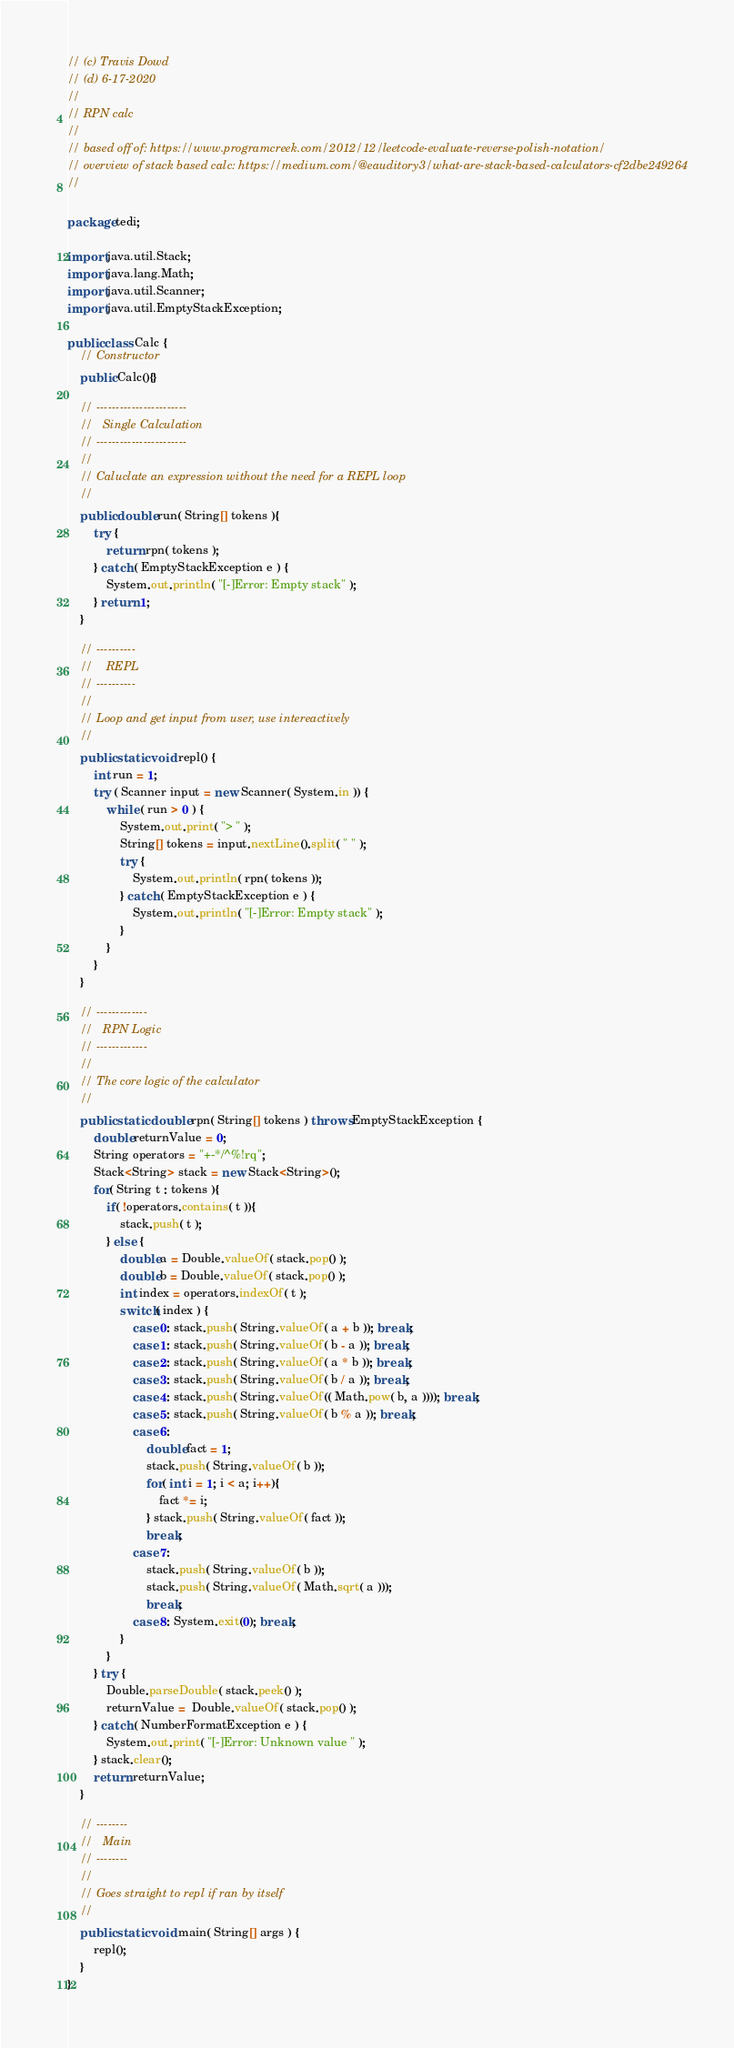Convert code to text. <code><loc_0><loc_0><loc_500><loc_500><_Java_>// (c) Travis Dowd
// (d) 6-17-2020
//
// RPN calc
//
// based off of: https://www.programcreek.com/2012/12/leetcode-evaluate-reverse-polish-notation/
// overview of stack based calc: https://medium.com/@eauditory3/what-are-stack-based-calculators-cf2dbe249264
//

package tedi;

import java.util.Stack;
import java.lang.Math;
import java.util.Scanner;
import java.util.EmptyStackException;

public class Calc {
	// Constructor
	public Calc(){}
	
	// -----------------------
	//   Single Calculation
	// -----------------------
	//
	// Caluclate an expression without the need for a REPL loop
	//
	public double run( String[] tokens ){
		try {
			return rpn( tokens );
		} catch ( EmptyStackException e ) {
			System.out.println( "[-]Error: Empty stack" );
		} return 1;
	}
	
	// ----------
	//    REPL
	// ----------
	//
	// Loop and get input from user, use intereactively
	//
	public static void repl() {
		int run = 1;
		try ( Scanner input = new Scanner( System.in )) {
			while ( run > 0 ) {
				System.out.print( "> " );
				String[] tokens = input.nextLine().split( " " );
				try { 
					System.out.println( rpn( tokens ));
				} catch ( EmptyStackException e ) {
					System.out.println( "[-]Error: Empty stack" );
				}
			}
		}
	}
	
	// -------------
	//   RPN Logic
	// -------------
	//
	// The core logic of the calculator
	//
	public static double rpn( String[] tokens ) throws EmptyStackException {
		double returnValue = 0;
		String operators = "+-*/^%!rq";
		Stack<String> stack = new Stack<String>();
		for( String t : tokens ){
			if( !operators.contains( t )){
				stack.push( t );
			} else {
				double a = Double.valueOf( stack.pop() );
				double b = Double.valueOf( stack.pop() );
				int index = operators.indexOf( t );
				switch( index ) {
					case 0: stack.push( String.valueOf( a + b )); break;
					case 1: stack.push( String.valueOf( b - a )); break;
					case 2: stack.push( String.valueOf( a * b )); break;
					case 3: stack.push( String.valueOf( b / a )); break;
					case 4: stack.push( String.valueOf(( Math.pow( b, a )))); break;
					case 5: stack.push( String.valueOf( b % a )); break;
					case 6: 
						double fact = 1;
						stack.push( String.valueOf( b ));
						for( int i = 1; i < a; i++){
							fact *= i;
						} stack.push( String.valueOf( fact ));
						break;
					case 7:
						stack.push( String.valueOf( b ));
						stack.push( String.valueOf( Math.sqrt( a )));
						break;
					case 8: System.exit(0); break;
				}
			}
		} try {
			Double.parseDouble( stack.peek() );
			returnValue =  Double.valueOf( stack.pop() );
		} catch ( NumberFormatException e ) {
			System.out.print( "[-]Error: Unknown value " );
		} stack.clear();
		return returnValue;
	}
	
	// --------
	//   Main
	// --------
	//
	// Goes straight to repl if ran by itself
	//
	public static void main( String[] args ) {
		repl();
	}
}
</code> 